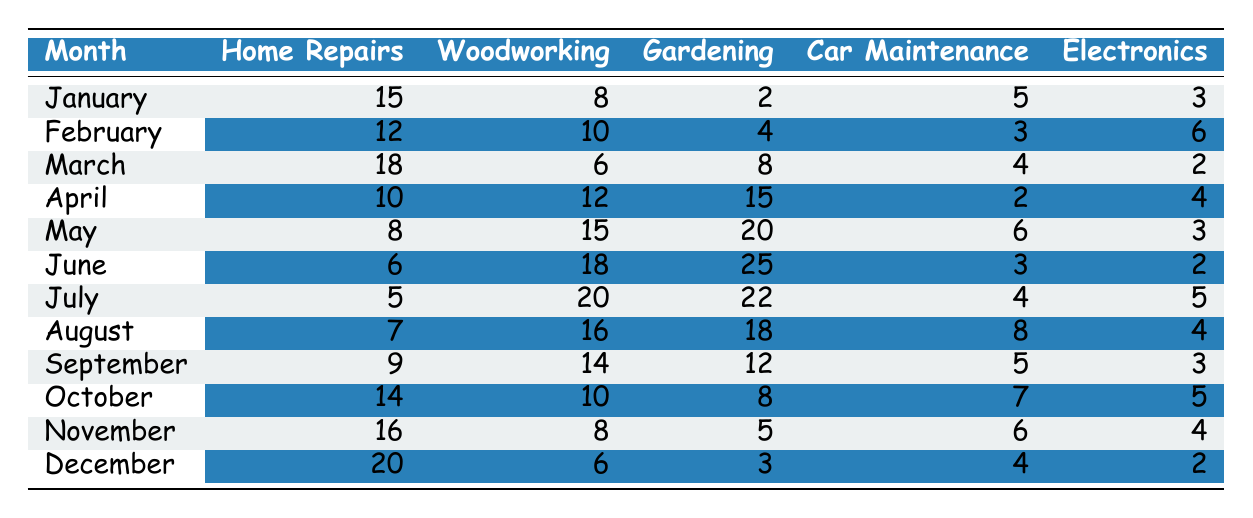What is the highest time spent on gardening in a single month? Looking at the Gardening column, the highest value is 25 in June.
Answer: 25 In which month did the couple spend the most time on woodworking? The highest woodworking time is 20 hours in July, as shown in the table.
Answer: July What was the total time spent on car maintenance throughout the year? Summing up the values in the Car Maintenance column gives 5 + 3 + 4 + 2 + 6 + 3 + 4 + 8 + 5 + 7 + 6 + 4 = 57.
Answer: 57 Did they spend more time on home repairs in March than in April? Home Repairs in March is 18 hours, while in April it is 10 hours. Thus, true.
Answer: Yes What is the average time spent on electronics over the year? The total time for Electronics is 3 + 6 + 2 + 4 + 3 + 2 + 5 + 4 + 3 + 5 + 4 + 2 = 43. Divided by 12 months gives an average of 43/12 ≈ 3.58.
Answer: 3.58 Which DIY project had the least total time spent throughout the year? The total for each project: Home Repairs = 15 + 12 + 18 + 10 + 8 + 6 + 5 + 7 + 9 + 14 + 16 + 20 =  112, Woodworking = 8 + 10 + 6 + 12 + 15 + 18 + 20 + 16 + 14 + 10 + 8 + 6 =  164, Gardening = 2 + 4 + 8 + 15 + 20 + 25 + 22 + 18 + 12 + 8 + 5 + 3 =  142, Car Maintenance = 5 + 3 + 4 + 2 + 6 + 3 + 4 + 8 + 5 + 7 + 6 + 4 = 57, Electronics = 3 + 6 + 2 + 4 + 3 + 2 + 5 + 4 + 3 + 5 + 4 + 2 = 43. So Electronics has the least at 43.
Answer: Electronics How much more time was spent on home repairs in December compared to January? Home Repairs in December is 20 hours, while in January it is 15 hours. The difference is 20 - 15 = 5.
Answer: 5 What percentage of the total hours in June were spent on gardening? In June, total hours = 6 + 18 + 25 + 3 + 2 = 54. Time spent on Gardening = 25. The percentage is (25/54) * 100 ≈ 46.3%.
Answer: 46.3% 